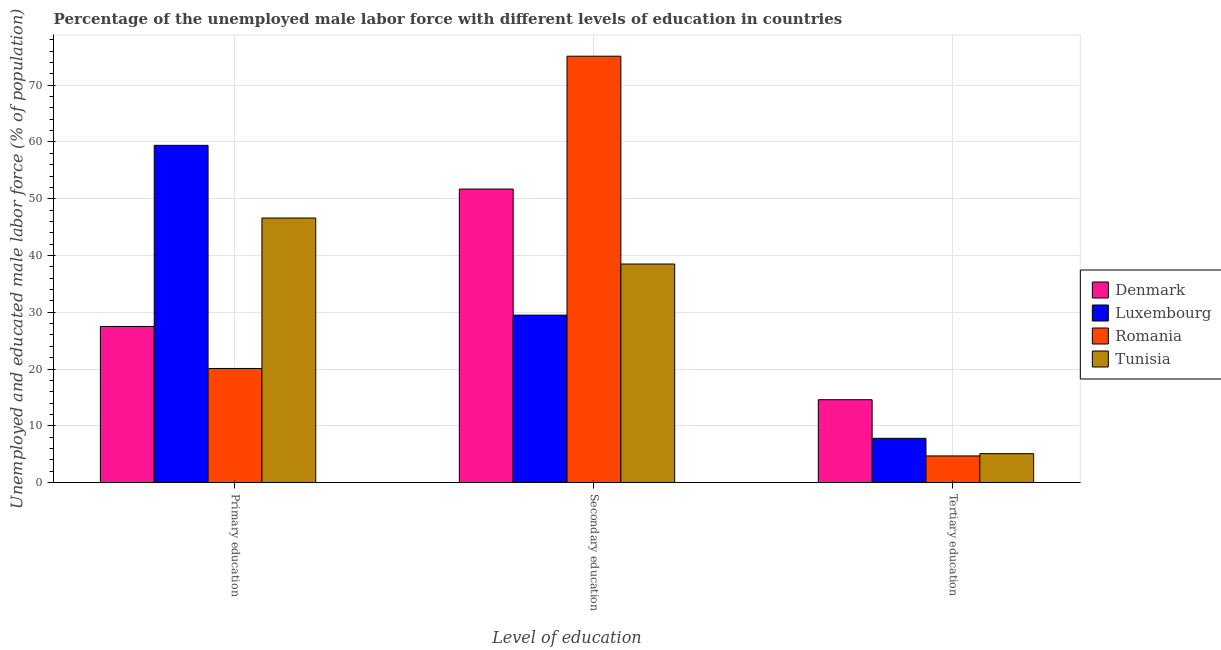How many groups of bars are there?
Your answer should be very brief. 3. Are the number of bars per tick equal to the number of legend labels?
Your answer should be compact. Yes. Are the number of bars on each tick of the X-axis equal?
Provide a succinct answer. Yes. What is the label of the 2nd group of bars from the left?
Give a very brief answer. Secondary education. What is the percentage of male labor force who received primary education in Luxembourg?
Your answer should be compact. 59.4. Across all countries, what is the maximum percentage of male labor force who received tertiary education?
Provide a short and direct response. 14.6. Across all countries, what is the minimum percentage of male labor force who received primary education?
Provide a short and direct response. 20.1. In which country was the percentage of male labor force who received tertiary education maximum?
Keep it short and to the point. Denmark. In which country was the percentage of male labor force who received primary education minimum?
Provide a short and direct response. Romania. What is the total percentage of male labor force who received primary education in the graph?
Offer a very short reply. 153.6. What is the average percentage of male labor force who received primary education per country?
Make the answer very short. 38.4. What is the difference between the percentage of male labor force who received primary education and percentage of male labor force who received secondary education in Tunisia?
Offer a terse response. 8.1. What is the ratio of the percentage of male labor force who received tertiary education in Romania to that in Tunisia?
Your answer should be compact. 0.92. What is the difference between the highest and the second highest percentage of male labor force who received secondary education?
Provide a short and direct response. 23.4. What is the difference between the highest and the lowest percentage of male labor force who received secondary education?
Your response must be concise. 45.6. In how many countries, is the percentage of male labor force who received primary education greater than the average percentage of male labor force who received primary education taken over all countries?
Provide a succinct answer. 2. What does the 4th bar from the left in Tertiary education represents?
Ensure brevity in your answer.  Tunisia. Is it the case that in every country, the sum of the percentage of male labor force who received primary education and percentage of male labor force who received secondary education is greater than the percentage of male labor force who received tertiary education?
Make the answer very short. Yes. How many bars are there?
Your response must be concise. 12. Are all the bars in the graph horizontal?
Give a very brief answer. No. Are the values on the major ticks of Y-axis written in scientific E-notation?
Your response must be concise. No. Does the graph contain grids?
Give a very brief answer. Yes. What is the title of the graph?
Give a very brief answer. Percentage of the unemployed male labor force with different levels of education in countries. Does "El Salvador" appear as one of the legend labels in the graph?
Ensure brevity in your answer.  No. What is the label or title of the X-axis?
Give a very brief answer. Level of education. What is the label or title of the Y-axis?
Keep it short and to the point. Unemployed and educated male labor force (% of population). What is the Unemployed and educated male labor force (% of population) of Luxembourg in Primary education?
Your answer should be very brief. 59.4. What is the Unemployed and educated male labor force (% of population) of Romania in Primary education?
Make the answer very short. 20.1. What is the Unemployed and educated male labor force (% of population) in Tunisia in Primary education?
Offer a very short reply. 46.6. What is the Unemployed and educated male labor force (% of population) of Denmark in Secondary education?
Provide a succinct answer. 51.7. What is the Unemployed and educated male labor force (% of population) in Luxembourg in Secondary education?
Offer a terse response. 29.5. What is the Unemployed and educated male labor force (% of population) in Romania in Secondary education?
Provide a short and direct response. 75.1. What is the Unemployed and educated male labor force (% of population) of Tunisia in Secondary education?
Your answer should be compact. 38.5. What is the Unemployed and educated male labor force (% of population) of Denmark in Tertiary education?
Your answer should be compact. 14.6. What is the Unemployed and educated male labor force (% of population) in Luxembourg in Tertiary education?
Your answer should be compact. 7.8. What is the Unemployed and educated male labor force (% of population) in Romania in Tertiary education?
Keep it short and to the point. 4.7. What is the Unemployed and educated male labor force (% of population) in Tunisia in Tertiary education?
Your answer should be very brief. 5.1. Across all Level of education, what is the maximum Unemployed and educated male labor force (% of population) in Denmark?
Provide a short and direct response. 51.7. Across all Level of education, what is the maximum Unemployed and educated male labor force (% of population) of Luxembourg?
Offer a terse response. 59.4. Across all Level of education, what is the maximum Unemployed and educated male labor force (% of population) of Romania?
Provide a succinct answer. 75.1. Across all Level of education, what is the maximum Unemployed and educated male labor force (% of population) of Tunisia?
Ensure brevity in your answer.  46.6. Across all Level of education, what is the minimum Unemployed and educated male labor force (% of population) of Denmark?
Your answer should be compact. 14.6. Across all Level of education, what is the minimum Unemployed and educated male labor force (% of population) in Luxembourg?
Offer a terse response. 7.8. Across all Level of education, what is the minimum Unemployed and educated male labor force (% of population) in Romania?
Provide a succinct answer. 4.7. Across all Level of education, what is the minimum Unemployed and educated male labor force (% of population) in Tunisia?
Offer a terse response. 5.1. What is the total Unemployed and educated male labor force (% of population) in Denmark in the graph?
Provide a succinct answer. 93.8. What is the total Unemployed and educated male labor force (% of population) in Luxembourg in the graph?
Offer a very short reply. 96.7. What is the total Unemployed and educated male labor force (% of population) in Romania in the graph?
Keep it short and to the point. 99.9. What is the total Unemployed and educated male labor force (% of population) of Tunisia in the graph?
Offer a very short reply. 90.2. What is the difference between the Unemployed and educated male labor force (% of population) in Denmark in Primary education and that in Secondary education?
Give a very brief answer. -24.2. What is the difference between the Unemployed and educated male labor force (% of population) of Luxembourg in Primary education and that in Secondary education?
Your answer should be very brief. 29.9. What is the difference between the Unemployed and educated male labor force (% of population) in Romania in Primary education and that in Secondary education?
Offer a very short reply. -55. What is the difference between the Unemployed and educated male labor force (% of population) in Luxembourg in Primary education and that in Tertiary education?
Provide a short and direct response. 51.6. What is the difference between the Unemployed and educated male labor force (% of population) of Tunisia in Primary education and that in Tertiary education?
Your answer should be compact. 41.5. What is the difference between the Unemployed and educated male labor force (% of population) of Denmark in Secondary education and that in Tertiary education?
Offer a very short reply. 37.1. What is the difference between the Unemployed and educated male labor force (% of population) in Luxembourg in Secondary education and that in Tertiary education?
Keep it short and to the point. 21.7. What is the difference between the Unemployed and educated male labor force (% of population) in Romania in Secondary education and that in Tertiary education?
Provide a succinct answer. 70.4. What is the difference between the Unemployed and educated male labor force (% of population) of Tunisia in Secondary education and that in Tertiary education?
Your answer should be compact. 33.4. What is the difference between the Unemployed and educated male labor force (% of population) in Denmark in Primary education and the Unemployed and educated male labor force (% of population) in Luxembourg in Secondary education?
Your answer should be very brief. -2. What is the difference between the Unemployed and educated male labor force (% of population) of Denmark in Primary education and the Unemployed and educated male labor force (% of population) of Romania in Secondary education?
Keep it short and to the point. -47.6. What is the difference between the Unemployed and educated male labor force (% of population) in Denmark in Primary education and the Unemployed and educated male labor force (% of population) in Tunisia in Secondary education?
Provide a succinct answer. -11. What is the difference between the Unemployed and educated male labor force (% of population) in Luxembourg in Primary education and the Unemployed and educated male labor force (% of population) in Romania in Secondary education?
Keep it short and to the point. -15.7. What is the difference between the Unemployed and educated male labor force (% of population) in Luxembourg in Primary education and the Unemployed and educated male labor force (% of population) in Tunisia in Secondary education?
Make the answer very short. 20.9. What is the difference between the Unemployed and educated male labor force (% of population) of Romania in Primary education and the Unemployed and educated male labor force (% of population) of Tunisia in Secondary education?
Offer a very short reply. -18.4. What is the difference between the Unemployed and educated male labor force (% of population) of Denmark in Primary education and the Unemployed and educated male labor force (% of population) of Romania in Tertiary education?
Offer a very short reply. 22.8. What is the difference between the Unemployed and educated male labor force (% of population) in Denmark in Primary education and the Unemployed and educated male labor force (% of population) in Tunisia in Tertiary education?
Your answer should be compact. 22.4. What is the difference between the Unemployed and educated male labor force (% of population) in Luxembourg in Primary education and the Unemployed and educated male labor force (% of population) in Romania in Tertiary education?
Provide a short and direct response. 54.7. What is the difference between the Unemployed and educated male labor force (% of population) in Luxembourg in Primary education and the Unemployed and educated male labor force (% of population) in Tunisia in Tertiary education?
Your answer should be very brief. 54.3. What is the difference between the Unemployed and educated male labor force (% of population) in Romania in Primary education and the Unemployed and educated male labor force (% of population) in Tunisia in Tertiary education?
Provide a short and direct response. 15. What is the difference between the Unemployed and educated male labor force (% of population) in Denmark in Secondary education and the Unemployed and educated male labor force (% of population) in Luxembourg in Tertiary education?
Your response must be concise. 43.9. What is the difference between the Unemployed and educated male labor force (% of population) of Denmark in Secondary education and the Unemployed and educated male labor force (% of population) of Romania in Tertiary education?
Offer a very short reply. 47. What is the difference between the Unemployed and educated male labor force (% of population) of Denmark in Secondary education and the Unemployed and educated male labor force (% of population) of Tunisia in Tertiary education?
Offer a very short reply. 46.6. What is the difference between the Unemployed and educated male labor force (% of population) in Luxembourg in Secondary education and the Unemployed and educated male labor force (% of population) in Romania in Tertiary education?
Keep it short and to the point. 24.8. What is the difference between the Unemployed and educated male labor force (% of population) in Luxembourg in Secondary education and the Unemployed and educated male labor force (% of population) in Tunisia in Tertiary education?
Offer a terse response. 24.4. What is the average Unemployed and educated male labor force (% of population) of Denmark per Level of education?
Offer a terse response. 31.27. What is the average Unemployed and educated male labor force (% of population) of Luxembourg per Level of education?
Provide a succinct answer. 32.23. What is the average Unemployed and educated male labor force (% of population) of Romania per Level of education?
Ensure brevity in your answer.  33.3. What is the average Unemployed and educated male labor force (% of population) in Tunisia per Level of education?
Offer a very short reply. 30.07. What is the difference between the Unemployed and educated male labor force (% of population) of Denmark and Unemployed and educated male labor force (% of population) of Luxembourg in Primary education?
Ensure brevity in your answer.  -31.9. What is the difference between the Unemployed and educated male labor force (% of population) of Denmark and Unemployed and educated male labor force (% of population) of Romania in Primary education?
Your response must be concise. 7.4. What is the difference between the Unemployed and educated male labor force (% of population) of Denmark and Unemployed and educated male labor force (% of population) of Tunisia in Primary education?
Your answer should be very brief. -19.1. What is the difference between the Unemployed and educated male labor force (% of population) of Luxembourg and Unemployed and educated male labor force (% of population) of Romania in Primary education?
Your response must be concise. 39.3. What is the difference between the Unemployed and educated male labor force (% of population) in Luxembourg and Unemployed and educated male labor force (% of population) in Tunisia in Primary education?
Your answer should be compact. 12.8. What is the difference between the Unemployed and educated male labor force (% of population) in Romania and Unemployed and educated male labor force (% of population) in Tunisia in Primary education?
Offer a terse response. -26.5. What is the difference between the Unemployed and educated male labor force (% of population) of Denmark and Unemployed and educated male labor force (% of population) of Luxembourg in Secondary education?
Your response must be concise. 22.2. What is the difference between the Unemployed and educated male labor force (% of population) of Denmark and Unemployed and educated male labor force (% of population) of Romania in Secondary education?
Provide a short and direct response. -23.4. What is the difference between the Unemployed and educated male labor force (% of population) in Luxembourg and Unemployed and educated male labor force (% of population) in Romania in Secondary education?
Keep it short and to the point. -45.6. What is the difference between the Unemployed and educated male labor force (% of population) of Romania and Unemployed and educated male labor force (% of population) of Tunisia in Secondary education?
Your answer should be very brief. 36.6. What is the difference between the Unemployed and educated male labor force (% of population) in Denmark and Unemployed and educated male labor force (% of population) in Luxembourg in Tertiary education?
Offer a very short reply. 6.8. What is the difference between the Unemployed and educated male labor force (% of population) of Denmark and Unemployed and educated male labor force (% of population) of Romania in Tertiary education?
Your answer should be very brief. 9.9. What is the difference between the Unemployed and educated male labor force (% of population) in Denmark and Unemployed and educated male labor force (% of population) in Tunisia in Tertiary education?
Ensure brevity in your answer.  9.5. What is the difference between the Unemployed and educated male labor force (% of population) of Romania and Unemployed and educated male labor force (% of population) of Tunisia in Tertiary education?
Provide a succinct answer. -0.4. What is the ratio of the Unemployed and educated male labor force (% of population) in Denmark in Primary education to that in Secondary education?
Your answer should be compact. 0.53. What is the ratio of the Unemployed and educated male labor force (% of population) in Luxembourg in Primary education to that in Secondary education?
Offer a very short reply. 2.01. What is the ratio of the Unemployed and educated male labor force (% of population) in Romania in Primary education to that in Secondary education?
Ensure brevity in your answer.  0.27. What is the ratio of the Unemployed and educated male labor force (% of population) of Tunisia in Primary education to that in Secondary education?
Ensure brevity in your answer.  1.21. What is the ratio of the Unemployed and educated male labor force (% of population) in Denmark in Primary education to that in Tertiary education?
Ensure brevity in your answer.  1.88. What is the ratio of the Unemployed and educated male labor force (% of population) of Luxembourg in Primary education to that in Tertiary education?
Provide a short and direct response. 7.62. What is the ratio of the Unemployed and educated male labor force (% of population) of Romania in Primary education to that in Tertiary education?
Ensure brevity in your answer.  4.28. What is the ratio of the Unemployed and educated male labor force (% of population) of Tunisia in Primary education to that in Tertiary education?
Make the answer very short. 9.14. What is the ratio of the Unemployed and educated male labor force (% of population) in Denmark in Secondary education to that in Tertiary education?
Offer a very short reply. 3.54. What is the ratio of the Unemployed and educated male labor force (% of population) in Luxembourg in Secondary education to that in Tertiary education?
Your response must be concise. 3.78. What is the ratio of the Unemployed and educated male labor force (% of population) of Romania in Secondary education to that in Tertiary education?
Your answer should be very brief. 15.98. What is the ratio of the Unemployed and educated male labor force (% of population) in Tunisia in Secondary education to that in Tertiary education?
Make the answer very short. 7.55. What is the difference between the highest and the second highest Unemployed and educated male labor force (% of population) in Denmark?
Offer a very short reply. 24.2. What is the difference between the highest and the second highest Unemployed and educated male labor force (% of population) of Luxembourg?
Ensure brevity in your answer.  29.9. What is the difference between the highest and the second highest Unemployed and educated male labor force (% of population) in Romania?
Give a very brief answer. 55. What is the difference between the highest and the lowest Unemployed and educated male labor force (% of population) of Denmark?
Ensure brevity in your answer.  37.1. What is the difference between the highest and the lowest Unemployed and educated male labor force (% of population) in Luxembourg?
Give a very brief answer. 51.6. What is the difference between the highest and the lowest Unemployed and educated male labor force (% of population) of Romania?
Offer a very short reply. 70.4. What is the difference between the highest and the lowest Unemployed and educated male labor force (% of population) of Tunisia?
Make the answer very short. 41.5. 